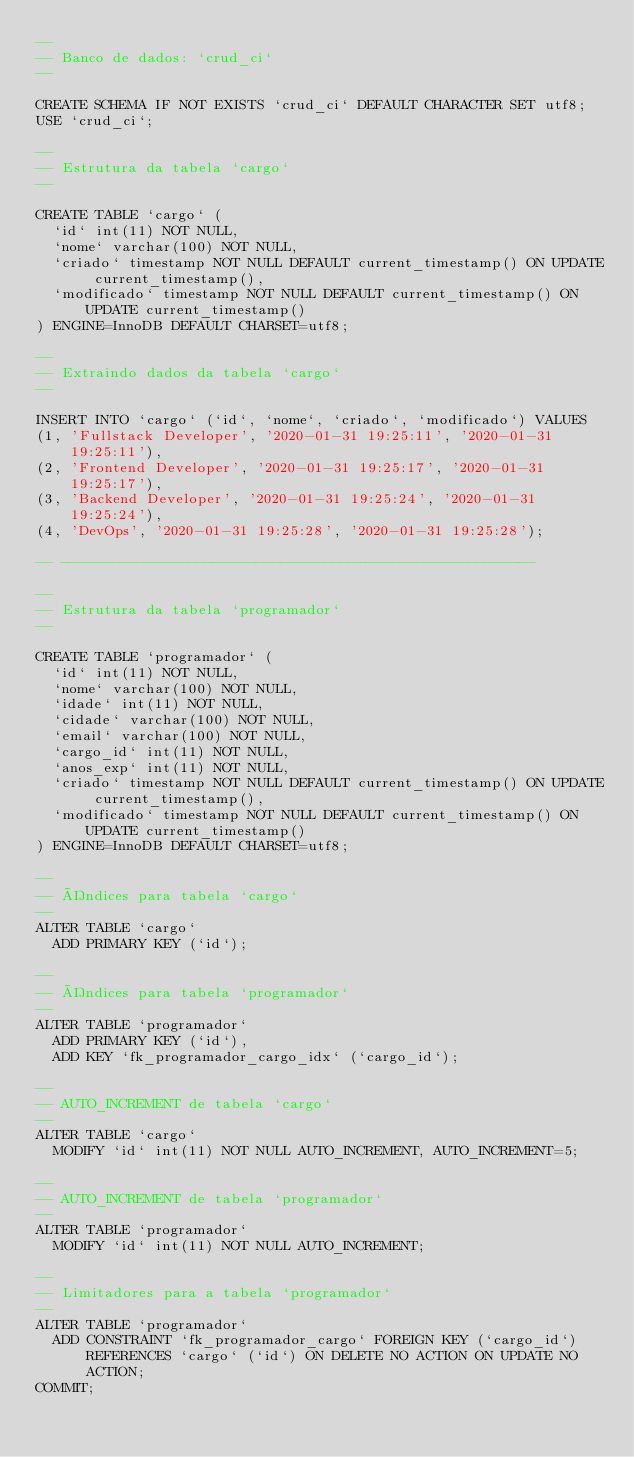<code> <loc_0><loc_0><loc_500><loc_500><_SQL_>--
-- Banco de dados: `crud_ci`
--

CREATE SCHEMA IF NOT EXISTS `crud_ci` DEFAULT CHARACTER SET utf8;
USE `crud_ci`;

--
-- Estrutura da tabela `cargo`
--

CREATE TABLE `cargo` (
  `id` int(11) NOT NULL,
  `nome` varchar(100) NOT NULL,
  `criado` timestamp NOT NULL DEFAULT current_timestamp() ON UPDATE current_timestamp(),
  `modificado` timestamp NOT NULL DEFAULT current_timestamp() ON UPDATE current_timestamp()
) ENGINE=InnoDB DEFAULT CHARSET=utf8;

--
-- Extraindo dados da tabela `cargo`
--

INSERT INTO `cargo` (`id`, `nome`, `criado`, `modificado`) VALUES
(1, 'Fullstack Developer', '2020-01-31 19:25:11', '2020-01-31 19:25:11'),
(2, 'Frontend Developer', '2020-01-31 19:25:17', '2020-01-31 19:25:17'),
(3, 'Backend Developer', '2020-01-31 19:25:24', '2020-01-31 19:25:24'),
(4, 'DevOps', '2020-01-31 19:25:28', '2020-01-31 19:25:28');

-- --------------------------------------------------------

--
-- Estrutura da tabela `programador`
--

CREATE TABLE `programador` (
  `id` int(11) NOT NULL,
  `nome` varchar(100) NOT NULL,
  `idade` int(11) NOT NULL,
  `cidade` varchar(100) NOT NULL,
  `email` varchar(100) NOT NULL,
  `cargo_id` int(11) NOT NULL,
  `anos_exp` int(11) NOT NULL,
  `criado` timestamp NOT NULL DEFAULT current_timestamp() ON UPDATE current_timestamp(),
  `modificado` timestamp NOT NULL DEFAULT current_timestamp() ON UPDATE current_timestamp()
) ENGINE=InnoDB DEFAULT CHARSET=utf8;

--
-- Índices para tabela `cargo`
--
ALTER TABLE `cargo`
  ADD PRIMARY KEY (`id`);

--
-- Índices para tabela `programador`
--
ALTER TABLE `programador`
  ADD PRIMARY KEY (`id`),
  ADD KEY `fk_programador_cargo_idx` (`cargo_id`);

--
-- AUTO_INCREMENT de tabela `cargo`
--
ALTER TABLE `cargo`
  MODIFY `id` int(11) NOT NULL AUTO_INCREMENT, AUTO_INCREMENT=5;

--
-- AUTO_INCREMENT de tabela `programador`
--
ALTER TABLE `programador`
  MODIFY `id` int(11) NOT NULL AUTO_INCREMENT;

--
-- Limitadores para a tabela `programador`
--
ALTER TABLE `programador`
  ADD CONSTRAINT `fk_programador_cargo` FOREIGN KEY (`cargo_id`) REFERENCES `cargo` (`id`) ON DELETE NO ACTION ON UPDATE NO ACTION;
COMMIT;</code> 